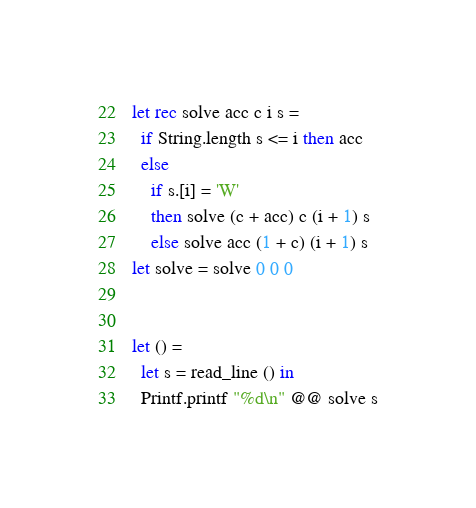Convert code to text. <code><loc_0><loc_0><loc_500><loc_500><_OCaml_>let rec solve acc c i s =
  if String.length s <= i then acc
  else
    if s.[i] = 'W'
    then solve (c + acc) c (i + 1) s
    else solve acc (1 + c) (i + 1) s
let solve = solve 0 0 0


let () =
  let s = read_line () in
  Printf.printf "%d\n" @@ solve s

</code> 